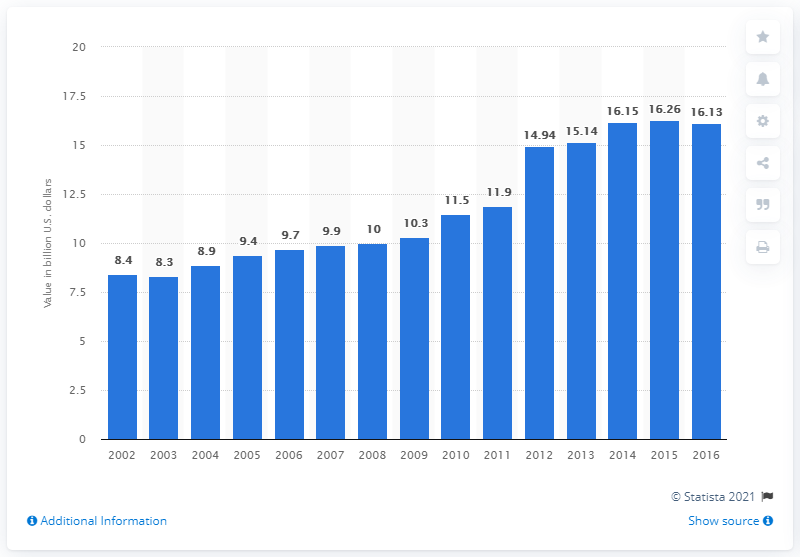Outline some significant characteristics in this image. In 2016, the value of U.S. product shipments of frozen dinners and nationality foods was 16.13. 